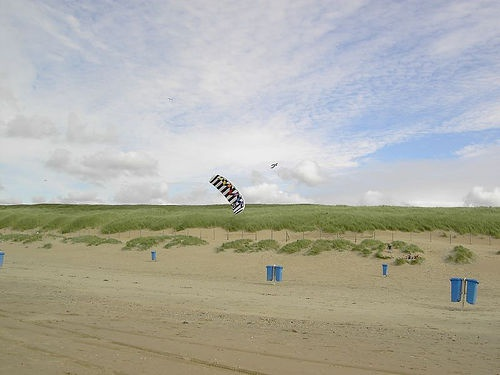Describe the objects in this image and their specific colors. I can see a kite in darkgray, black, lightgray, and gray tones in this image. 